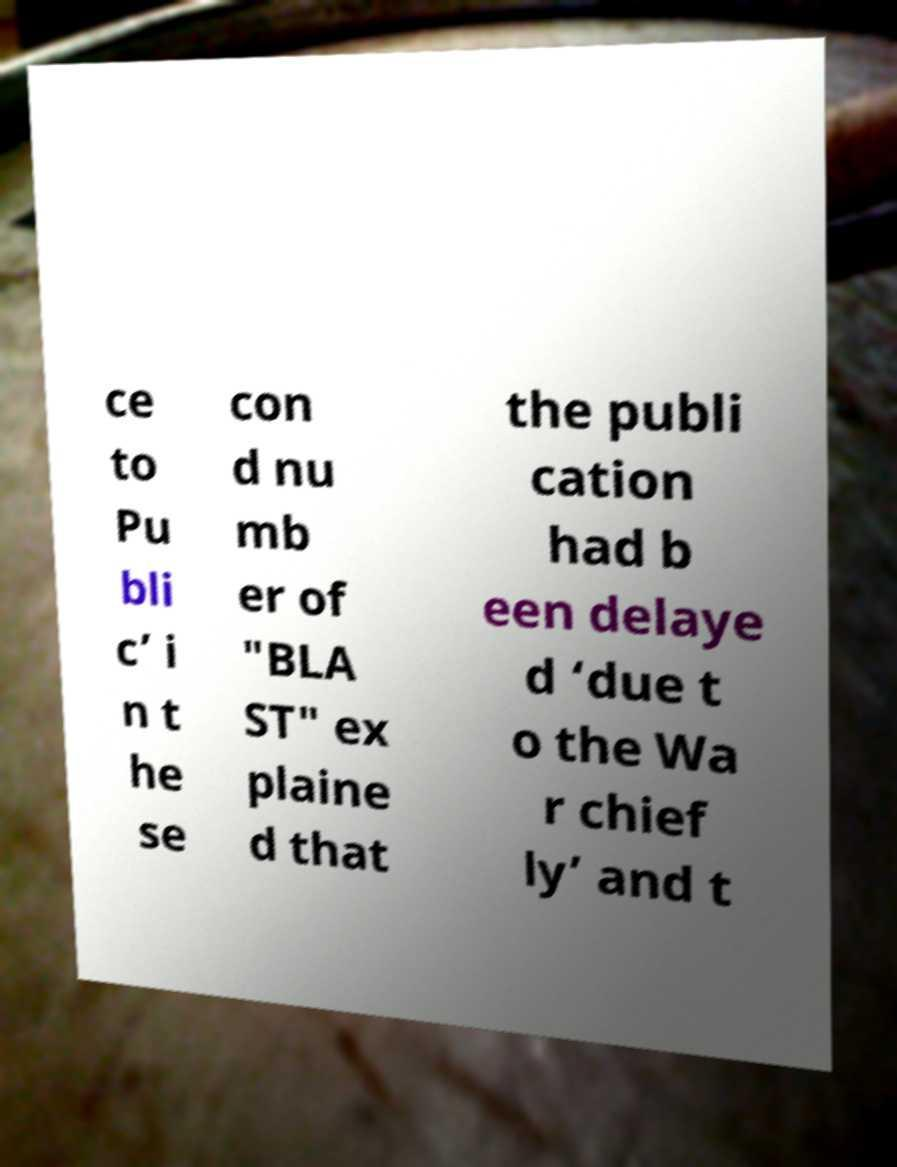Can you accurately transcribe the text from the provided image for me? ce to Pu bli c’ i n t he se con d nu mb er of "BLA ST" ex plaine d that the publi cation had b een delaye d ‘due t o the Wa r chief ly’ and t 